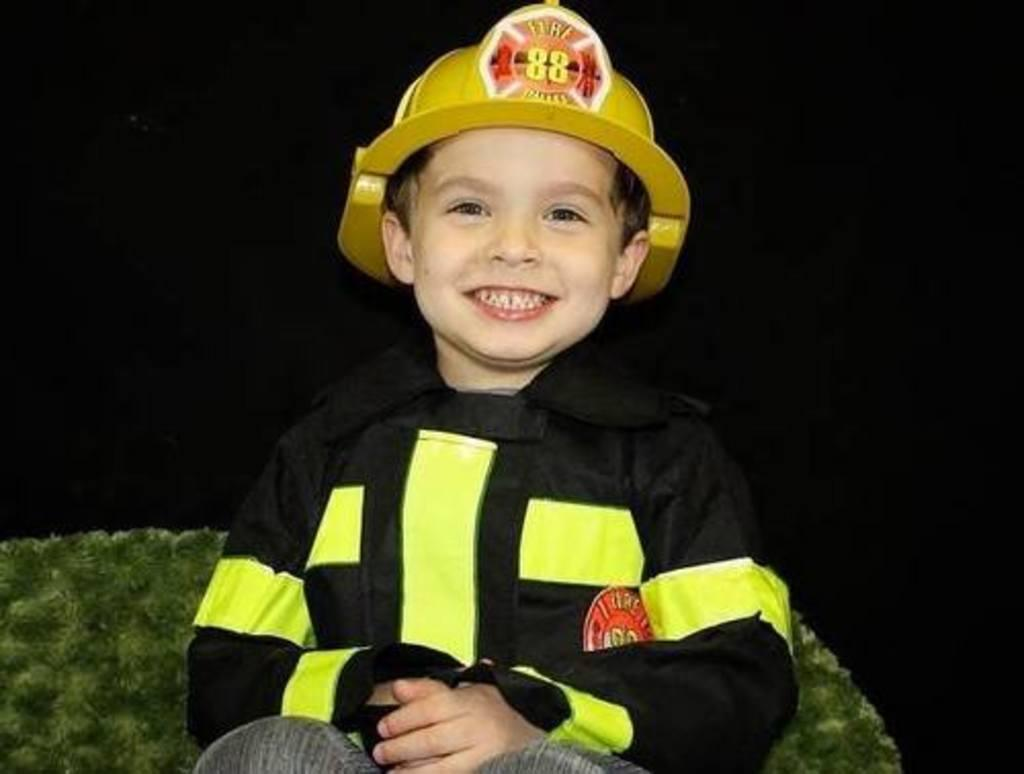What is the main subject in the foreground of the picture? There is a boy in the foreground of the picture. What is the boy wearing? The boy is wearing a firefighter dress and a helmet. What is the boy's facial expression? The boy is smiling. Where is the boy sitting? The boy is sitting on a couch. What is the color of the background in the image? The background of the image is dark. What type of clam can be seen in the boy's hand in the image? There is no clam present in the image; the boy is wearing a firefighter dress and a helmet. What type of space exploration is the boy participating in the image? There is no space exploration depicted in the image; the boy is dressed as a firefighter and sitting on a couch. 